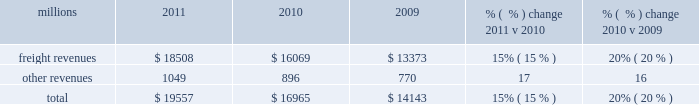F0b7 positive train control 2013 in response to a legislative mandate to implement ptc by the end of 2015 , we expect to spend approximately $ 335 million during 2012 on developing and deploying ptc .
We currently estimate that ptc in accordance with implementing rules issued by the federal rail administration ( fra ) will cost us approximately $ 2 billion by the end of 2015 .
This includes costs for installing the new system along our tracks , upgrading locomotives to work with the new system , and adding digital data communication equipment so all the parts of the system can communicate with each other .
During 2012 , we plan to continue testing the technology to evaluate its effectiveness .
F0b7 financial expectations 2013 we are cautious about the economic environment but anticipate slow but steady volume growth that will exceed 2011 levels .
Coupled with price , on-going network improvements and operational productivity initiatives , we expect earnings that exceed 2011 earnings .
Results of operations operating revenues millions 2011 2010 2009 % (  % ) change 2011 v 2010 % (  % ) change 2010 v 2009 .
We generate freight revenues by transporting freight or other materials from our six commodity groups .
Freight revenues vary with volume ( carloads ) and average revenue per car ( arc ) .
Changes in price , traffic mix and fuel surcharges drive arc .
We provide some of our customers with contractual incentives for meeting or exceeding specified cumulative volumes or shipping to and from specific locations , which we record as reductions to freight revenues based on the actual or projected future shipments .
We recognize freight revenues as shipments move from origin to destination .
We allocate freight revenues between reporting periods based on the relative transit time in each reporting period and recognize expenses as we incur them .
Other revenues include revenues earned by our subsidiaries , revenues from our commuter rail operations , and accessorial revenues , which we earn when customers retain equipment owned or controlled by us or when we perform additional services such as switching or storage .
We recognize other revenues as we perform services or meet contractual obligations .
Freight revenues for all six commodity groups increased during 2011 compared to 2010 , while volume increased in all except intermodal .
Increased demand in many market sectors , with particularly strong growth in chemical , industrial products , and automotive shipments for the year , generated the increases .
Arc increased 12% ( 12 % ) , driven by higher fuel cost recoveries and core pricing gains .
Fuel cost recoveries include fuel surcharge revenue and the impact of resetting the base fuel price for certain traffic , which is described below in more detail .
Higher fuel prices , volume growth , and new fuel surcharge provisions in renegotiated contracts all combined to increase revenues from fuel surcharges .
Freight revenues and volume levels for all six commodity groups increased during 2010 as a result of economic improvement in many market sectors .
We experienced particularly strong volume growth in automotive , intermodal , and industrial products shipments .
Core pricing gains and higher fuel surcharges also increased freight revenues and drove a 6% ( 6 % ) improvement in arc .
Our fuel surcharge programs ( excluding index-based contract escalators that contain some provision for fuel ) generated freight revenues of $ 2.2 billion , $ 1.2 billion , and $ 605 million in 2011 , 2010 , and 2009 , respectively .
Higher fuel prices , volume growth , and new fuel surcharge provisions in contracts renegotiated during the year increased fuel surcharge amounts in 2011 and 2010 .
Furthermore , for certain periods during 2009 , fuel prices dropped below the base at which our mileage-based fuel surcharge begins , which resulted in no fuel surcharge recovery for associated shipments during those periods .
Additionally , fuel surcharge revenue is not entirely comparable to prior periods as we continue to convert portions of our non-regulated traffic to mileage-based fuel surcharge programs .
In 2011 , other revenues increased from 2010 due primarily to higher revenues at our subsidiaries that broker intermodal and automotive services. .
Fuel surcharge programs represented what share of revenue in 2011? 
Computations: (2.2 / (19557 / 1000))
Answer: 0.11249. F0b7 positive train control 2013 in response to a legislative mandate to implement ptc by the end of 2015 , we expect to spend approximately $ 335 million during 2012 on developing and deploying ptc .
We currently estimate that ptc in accordance with implementing rules issued by the federal rail administration ( fra ) will cost us approximately $ 2 billion by the end of 2015 .
This includes costs for installing the new system along our tracks , upgrading locomotives to work with the new system , and adding digital data communication equipment so all the parts of the system can communicate with each other .
During 2012 , we plan to continue testing the technology to evaluate its effectiveness .
F0b7 financial expectations 2013 we are cautious about the economic environment but anticipate slow but steady volume growth that will exceed 2011 levels .
Coupled with price , on-going network improvements and operational productivity initiatives , we expect earnings that exceed 2011 earnings .
Results of operations operating revenues millions 2011 2010 2009 % (  % ) change 2011 v 2010 % (  % ) change 2010 v 2009 .
We generate freight revenues by transporting freight or other materials from our six commodity groups .
Freight revenues vary with volume ( carloads ) and average revenue per car ( arc ) .
Changes in price , traffic mix and fuel surcharges drive arc .
We provide some of our customers with contractual incentives for meeting or exceeding specified cumulative volumes or shipping to and from specific locations , which we record as reductions to freight revenues based on the actual or projected future shipments .
We recognize freight revenues as shipments move from origin to destination .
We allocate freight revenues between reporting periods based on the relative transit time in each reporting period and recognize expenses as we incur them .
Other revenues include revenues earned by our subsidiaries , revenues from our commuter rail operations , and accessorial revenues , which we earn when customers retain equipment owned or controlled by us or when we perform additional services such as switching or storage .
We recognize other revenues as we perform services or meet contractual obligations .
Freight revenues for all six commodity groups increased during 2011 compared to 2010 , while volume increased in all except intermodal .
Increased demand in many market sectors , with particularly strong growth in chemical , industrial products , and automotive shipments for the year , generated the increases .
Arc increased 12% ( 12 % ) , driven by higher fuel cost recoveries and core pricing gains .
Fuel cost recoveries include fuel surcharge revenue and the impact of resetting the base fuel price for certain traffic , which is described below in more detail .
Higher fuel prices , volume growth , and new fuel surcharge provisions in renegotiated contracts all combined to increase revenues from fuel surcharges .
Freight revenues and volume levels for all six commodity groups increased during 2010 as a result of economic improvement in many market sectors .
We experienced particularly strong volume growth in automotive , intermodal , and industrial products shipments .
Core pricing gains and higher fuel surcharges also increased freight revenues and drove a 6% ( 6 % ) improvement in arc .
Our fuel surcharge programs ( excluding index-based contract escalators that contain some provision for fuel ) generated freight revenues of $ 2.2 billion , $ 1.2 billion , and $ 605 million in 2011 , 2010 , and 2009 , respectively .
Higher fuel prices , volume growth , and new fuel surcharge provisions in contracts renegotiated during the year increased fuel surcharge amounts in 2011 and 2010 .
Furthermore , for certain periods during 2009 , fuel prices dropped below the base at which our mileage-based fuel surcharge begins , which resulted in no fuel surcharge recovery for associated shipments during those periods .
Additionally , fuel surcharge revenue is not entirely comparable to prior periods as we continue to convert portions of our non-regulated traffic to mileage-based fuel surcharge programs .
In 2011 , other revenues increased from 2010 due primarily to higher revenues at our subsidiaries that broker intermodal and automotive services. .
Fuel surcharge programs represented what share of revenue in 2010? 
Computations: (16965 / 1000)
Answer: 16.965. F0b7 positive train control 2013 in response to a legislative mandate to implement ptc by the end of 2015 , we expect to spend approximately $ 335 million during 2012 on developing and deploying ptc .
We currently estimate that ptc in accordance with implementing rules issued by the federal rail administration ( fra ) will cost us approximately $ 2 billion by the end of 2015 .
This includes costs for installing the new system along our tracks , upgrading locomotives to work with the new system , and adding digital data communication equipment so all the parts of the system can communicate with each other .
During 2012 , we plan to continue testing the technology to evaluate its effectiveness .
F0b7 financial expectations 2013 we are cautious about the economic environment but anticipate slow but steady volume growth that will exceed 2011 levels .
Coupled with price , on-going network improvements and operational productivity initiatives , we expect earnings that exceed 2011 earnings .
Results of operations operating revenues millions 2011 2010 2009 % (  % ) change 2011 v 2010 % (  % ) change 2010 v 2009 .
We generate freight revenues by transporting freight or other materials from our six commodity groups .
Freight revenues vary with volume ( carloads ) and average revenue per car ( arc ) .
Changes in price , traffic mix and fuel surcharges drive arc .
We provide some of our customers with contractual incentives for meeting or exceeding specified cumulative volumes or shipping to and from specific locations , which we record as reductions to freight revenues based on the actual or projected future shipments .
We recognize freight revenues as shipments move from origin to destination .
We allocate freight revenues between reporting periods based on the relative transit time in each reporting period and recognize expenses as we incur them .
Other revenues include revenues earned by our subsidiaries , revenues from our commuter rail operations , and accessorial revenues , which we earn when customers retain equipment owned or controlled by us or when we perform additional services such as switching or storage .
We recognize other revenues as we perform services or meet contractual obligations .
Freight revenues for all six commodity groups increased during 2011 compared to 2010 , while volume increased in all except intermodal .
Increased demand in many market sectors , with particularly strong growth in chemical , industrial products , and automotive shipments for the year , generated the increases .
Arc increased 12% ( 12 % ) , driven by higher fuel cost recoveries and core pricing gains .
Fuel cost recoveries include fuel surcharge revenue and the impact of resetting the base fuel price for certain traffic , which is described below in more detail .
Higher fuel prices , volume growth , and new fuel surcharge provisions in renegotiated contracts all combined to increase revenues from fuel surcharges .
Freight revenues and volume levels for all six commodity groups increased during 2010 as a result of economic improvement in many market sectors .
We experienced particularly strong volume growth in automotive , intermodal , and industrial products shipments .
Core pricing gains and higher fuel surcharges also increased freight revenues and drove a 6% ( 6 % ) improvement in arc .
Our fuel surcharge programs ( excluding index-based contract escalators that contain some provision for fuel ) generated freight revenues of $ 2.2 billion , $ 1.2 billion , and $ 605 million in 2011 , 2010 , and 2009 , respectively .
Higher fuel prices , volume growth , and new fuel surcharge provisions in contracts renegotiated during the year increased fuel surcharge amounts in 2011 and 2010 .
Furthermore , for certain periods during 2009 , fuel prices dropped below the base at which our mileage-based fuel surcharge begins , which resulted in no fuel surcharge recovery for associated shipments during those periods .
Additionally , fuel surcharge revenue is not entirely comparable to prior periods as we continue to convert portions of our non-regulated traffic to mileage-based fuel surcharge programs .
In 2011 , other revenues increased from 2010 due primarily to higher revenues at our subsidiaries that broker intermodal and automotive services. .
What percentage of total revenue in 2010 was freight revenue? 
Computations: (16069 / 16965)
Answer: 0.94719. 